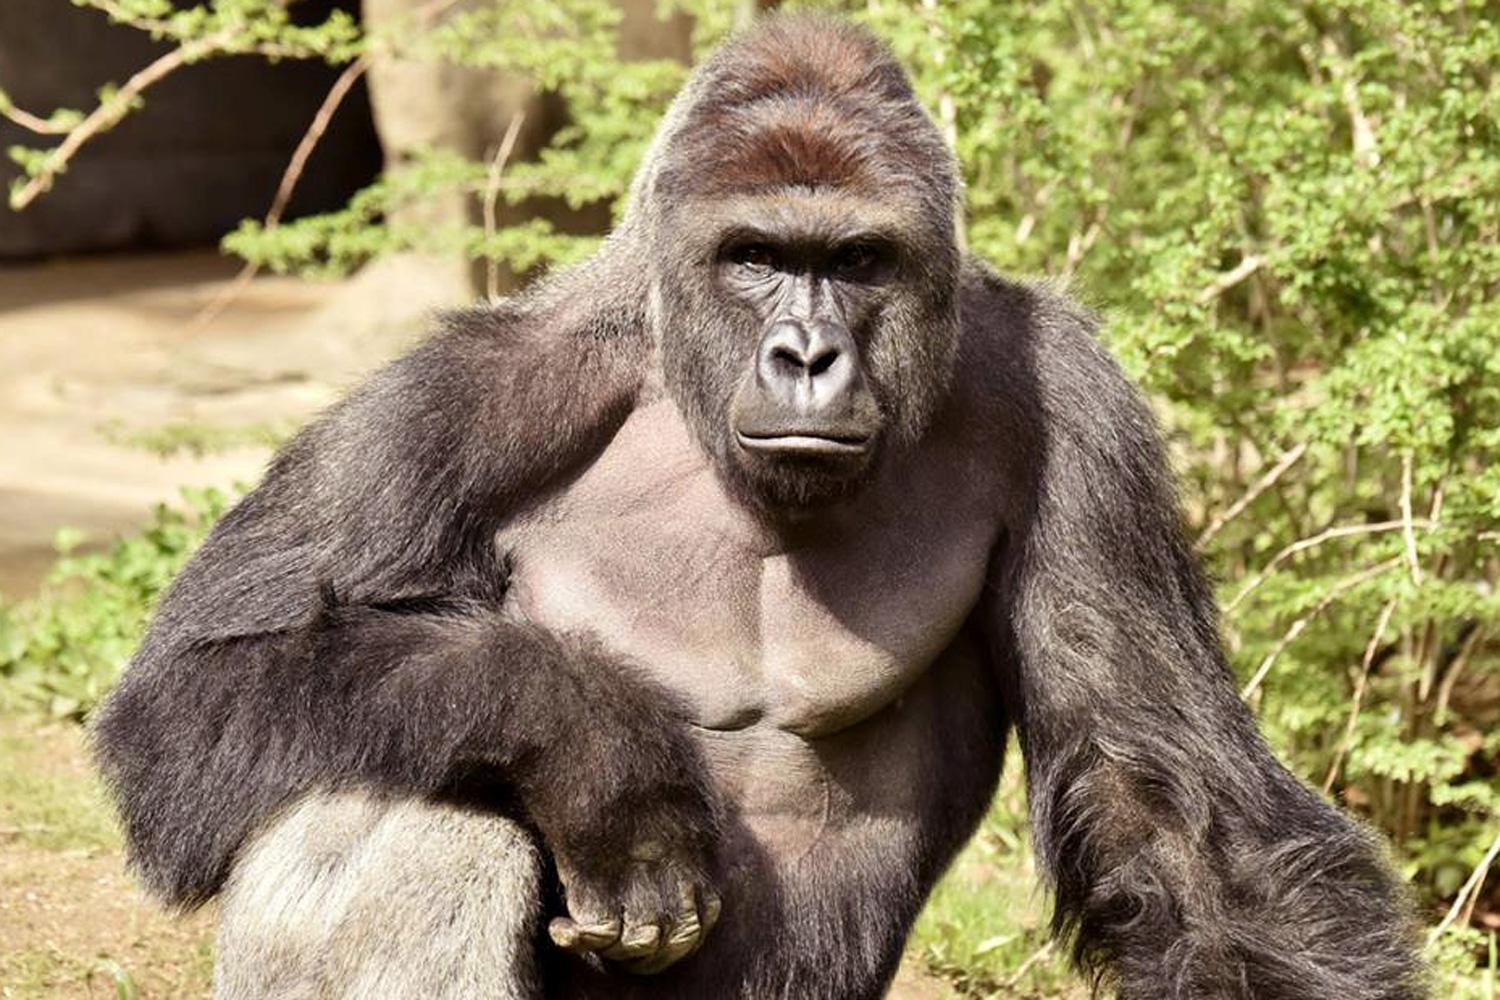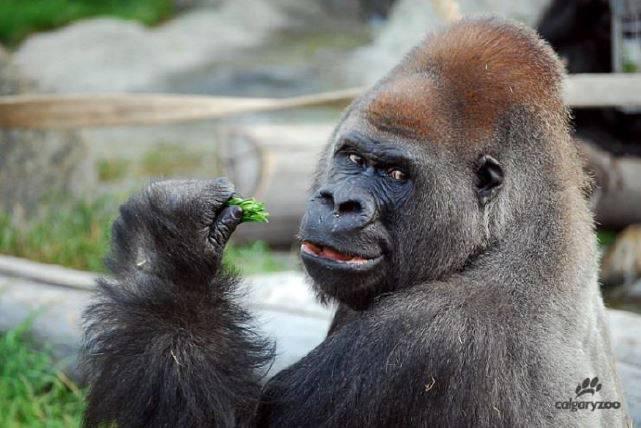The first image is the image on the left, the second image is the image on the right. Evaluate the accuracy of this statement regarding the images: "No image contains more than one gorilla, and each gorilla is gazing in a way that its eyes are visible.". Is it true? Answer yes or no. Yes. The first image is the image on the left, the second image is the image on the right. For the images shown, is this caption "The ape on the right is eating something." true? Answer yes or no. Yes. 